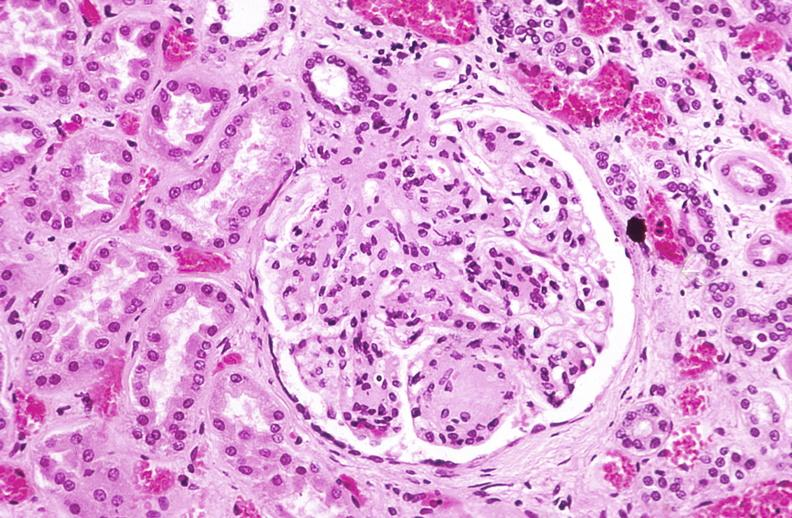where is this?
Answer the question using a single word or phrase. Urinary 